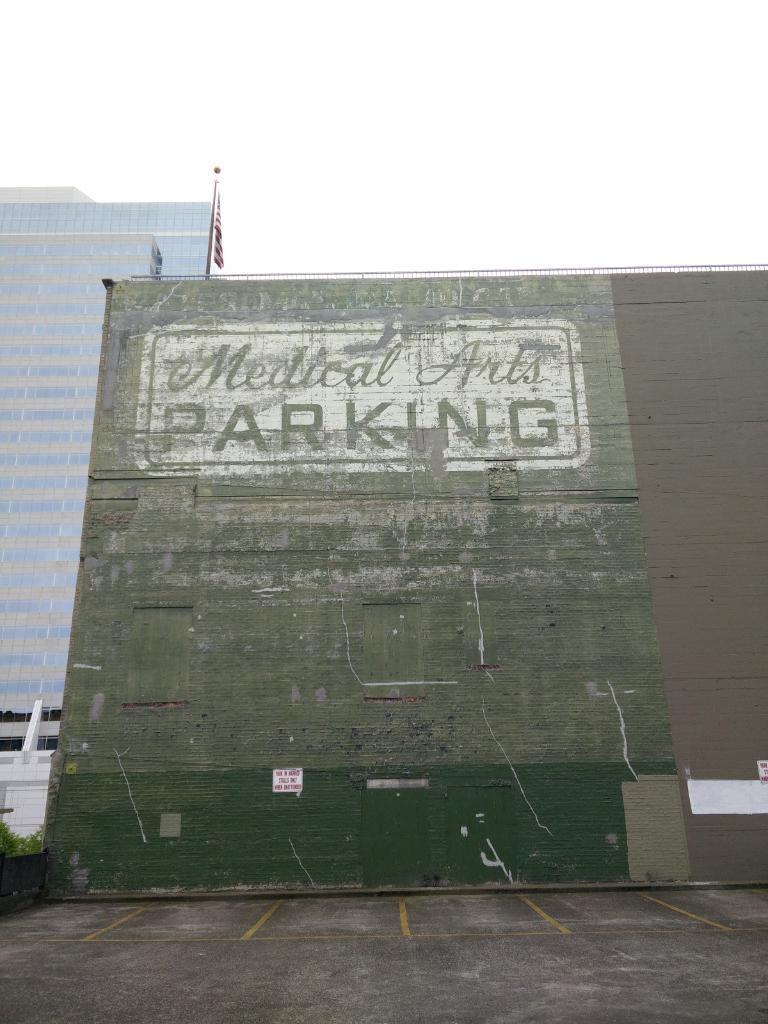In one or two sentences, can you explain what this image depicts? In this image we can see the wall on which we can see some text. Here we can see plants, flag to the pole, tower buildings and the sky in the background. 